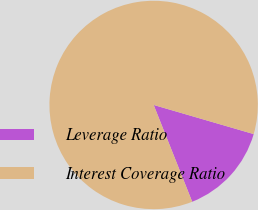<chart> <loc_0><loc_0><loc_500><loc_500><pie_chart><fcel>Leverage Ratio<fcel>Interest Coverage Ratio<nl><fcel>14.46%<fcel>85.54%<nl></chart> 